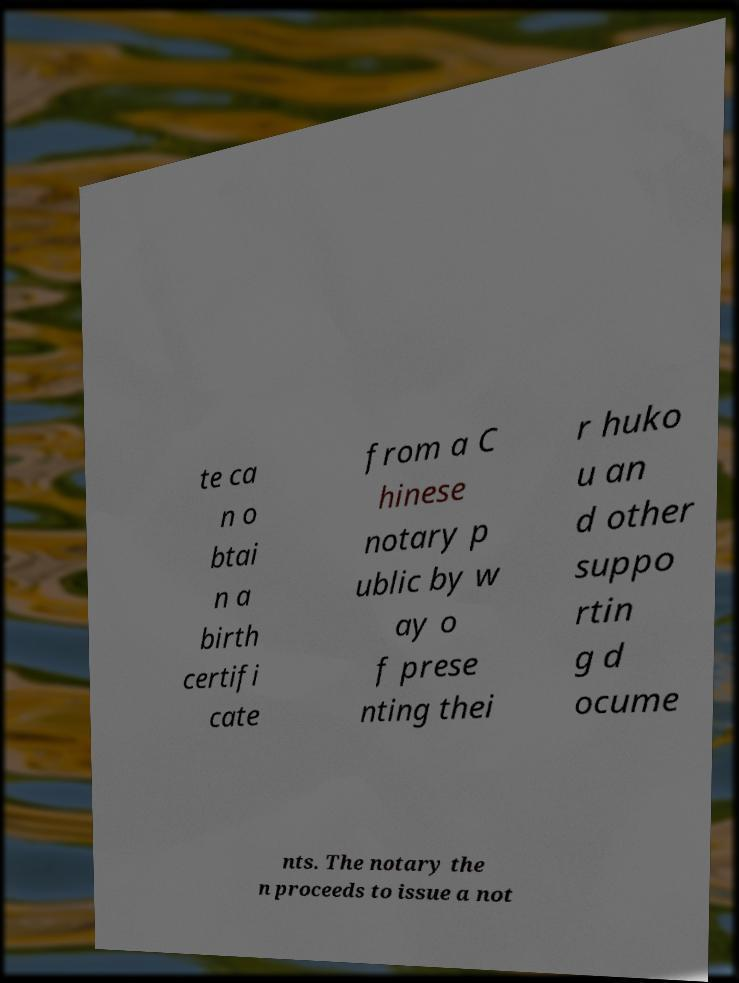I need the written content from this picture converted into text. Can you do that? te ca n o btai n a birth certifi cate from a C hinese notary p ublic by w ay o f prese nting thei r huko u an d other suppo rtin g d ocume nts. The notary the n proceeds to issue a not 